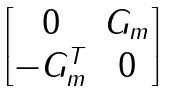Convert formula to latex. <formula><loc_0><loc_0><loc_500><loc_500>\begin{bmatrix} 0 & G _ { m } \\ - G ^ { T } _ { m } & 0 \\ \end{bmatrix}</formula> 